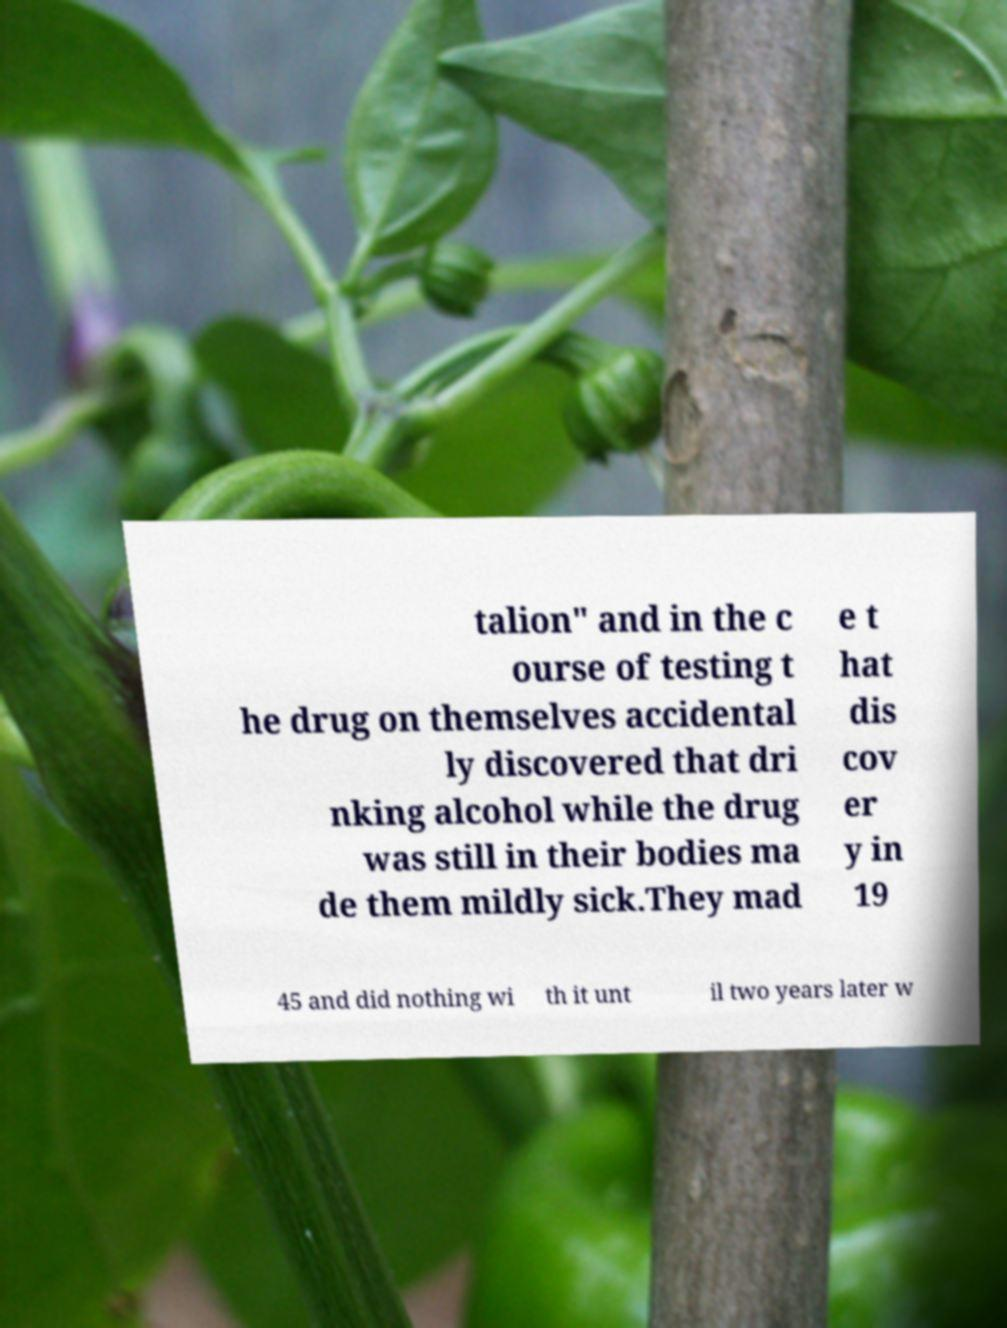Could you assist in decoding the text presented in this image and type it out clearly? talion" and in the c ourse of testing t he drug on themselves accidental ly discovered that dri nking alcohol while the drug was still in their bodies ma de them mildly sick.They mad e t hat dis cov er y in 19 45 and did nothing wi th it unt il two years later w 